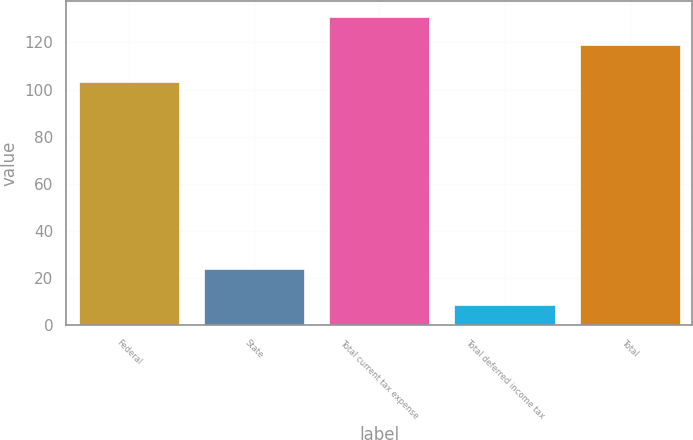Convert chart to OTSL. <chart><loc_0><loc_0><loc_500><loc_500><bar_chart><fcel>Federal<fcel>State<fcel>Total current tax expense<fcel>Total deferred income tax<fcel>Total<nl><fcel>103.3<fcel>23.9<fcel>130.9<fcel>8.3<fcel>119<nl></chart> 